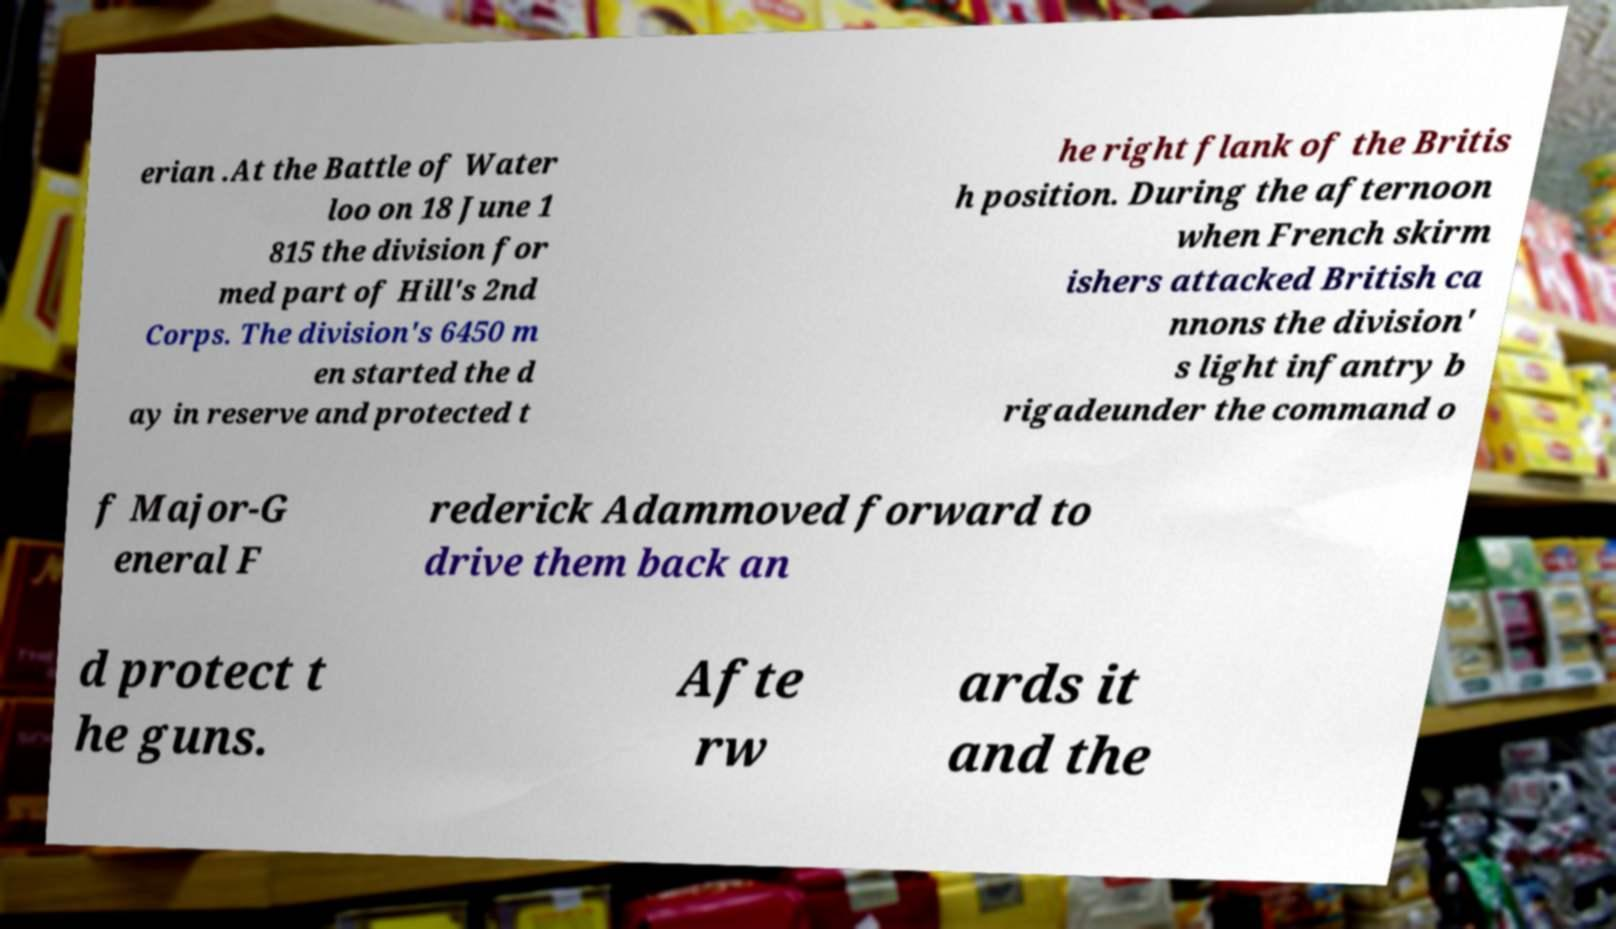Can you read and provide the text displayed in the image?This photo seems to have some interesting text. Can you extract and type it out for me? erian .At the Battle of Water loo on 18 June 1 815 the division for med part of Hill's 2nd Corps. The division's 6450 m en started the d ay in reserve and protected t he right flank of the Britis h position. During the afternoon when French skirm ishers attacked British ca nnons the division' s light infantry b rigadeunder the command o f Major-G eneral F rederick Adammoved forward to drive them back an d protect t he guns. Afte rw ards it and the 